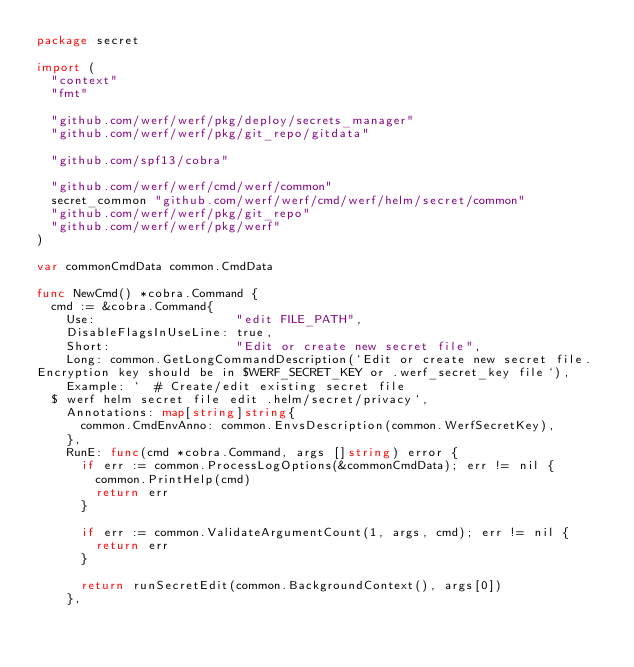Convert code to text. <code><loc_0><loc_0><loc_500><loc_500><_Go_>package secret

import (
	"context"
	"fmt"

	"github.com/werf/werf/pkg/deploy/secrets_manager"
	"github.com/werf/werf/pkg/git_repo/gitdata"

	"github.com/spf13/cobra"

	"github.com/werf/werf/cmd/werf/common"
	secret_common "github.com/werf/werf/cmd/werf/helm/secret/common"
	"github.com/werf/werf/pkg/git_repo"
	"github.com/werf/werf/pkg/werf"
)

var commonCmdData common.CmdData

func NewCmd() *cobra.Command {
	cmd := &cobra.Command{
		Use:                   "edit FILE_PATH",
		DisableFlagsInUseLine: true,
		Short:                 "Edit or create new secret file",
		Long: common.GetLongCommandDescription(`Edit or create new secret file.
Encryption key should be in $WERF_SECRET_KEY or .werf_secret_key file`),
		Example: `  # Create/edit existing secret file
  $ werf helm secret file edit .helm/secret/privacy`,
		Annotations: map[string]string{
			common.CmdEnvAnno: common.EnvsDescription(common.WerfSecretKey),
		},
		RunE: func(cmd *cobra.Command, args []string) error {
			if err := common.ProcessLogOptions(&commonCmdData); err != nil {
				common.PrintHelp(cmd)
				return err
			}

			if err := common.ValidateArgumentCount(1, args, cmd); err != nil {
				return err
			}

			return runSecretEdit(common.BackgroundContext(), args[0])
		},</code> 